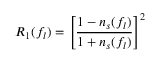Convert formula to latex. <formula><loc_0><loc_0><loc_500><loc_500>R _ { 1 } ( f _ { l } ) = \left [ \frac { 1 - n _ { s } ( f _ { l } ) } { 1 + n _ { s } ( f _ { l } ) } \right ] ^ { 2 }</formula> 